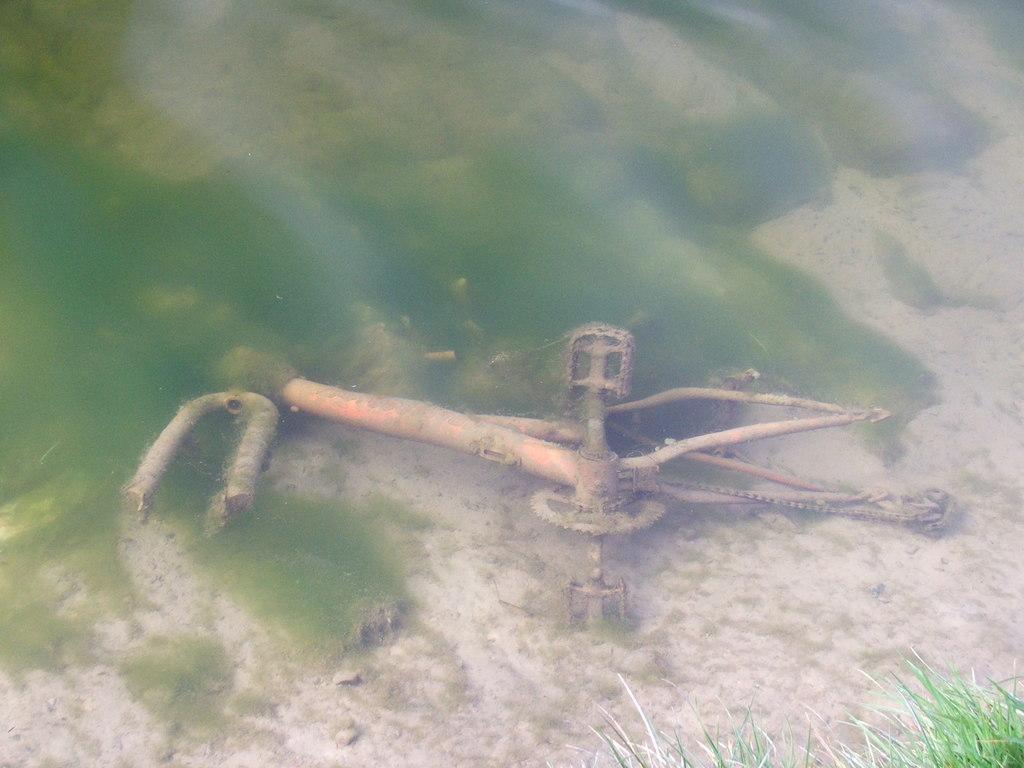Describe this image in one or two sentences. In this image, it seems like a metal object and grass in the foreground. 